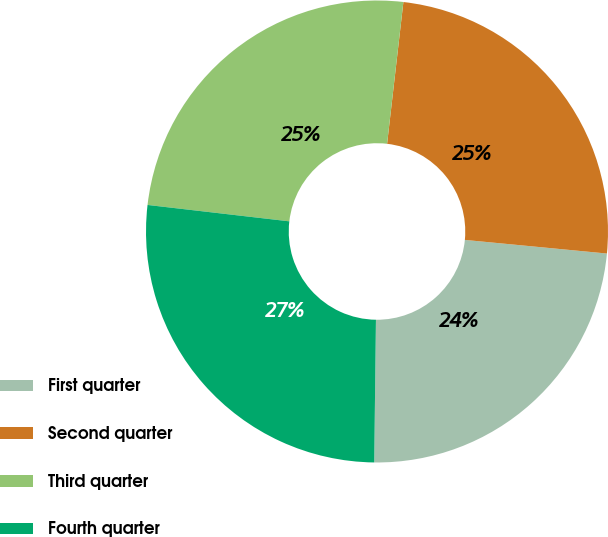Convert chart to OTSL. <chart><loc_0><loc_0><loc_500><loc_500><pie_chart><fcel>First quarter<fcel>Second quarter<fcel>Third quarter<fcel>Fourth quarter<nl><fcel>23.67%<fcel>24.7%<fcel>24.99%<fcel>26.64%<nl></chart> 